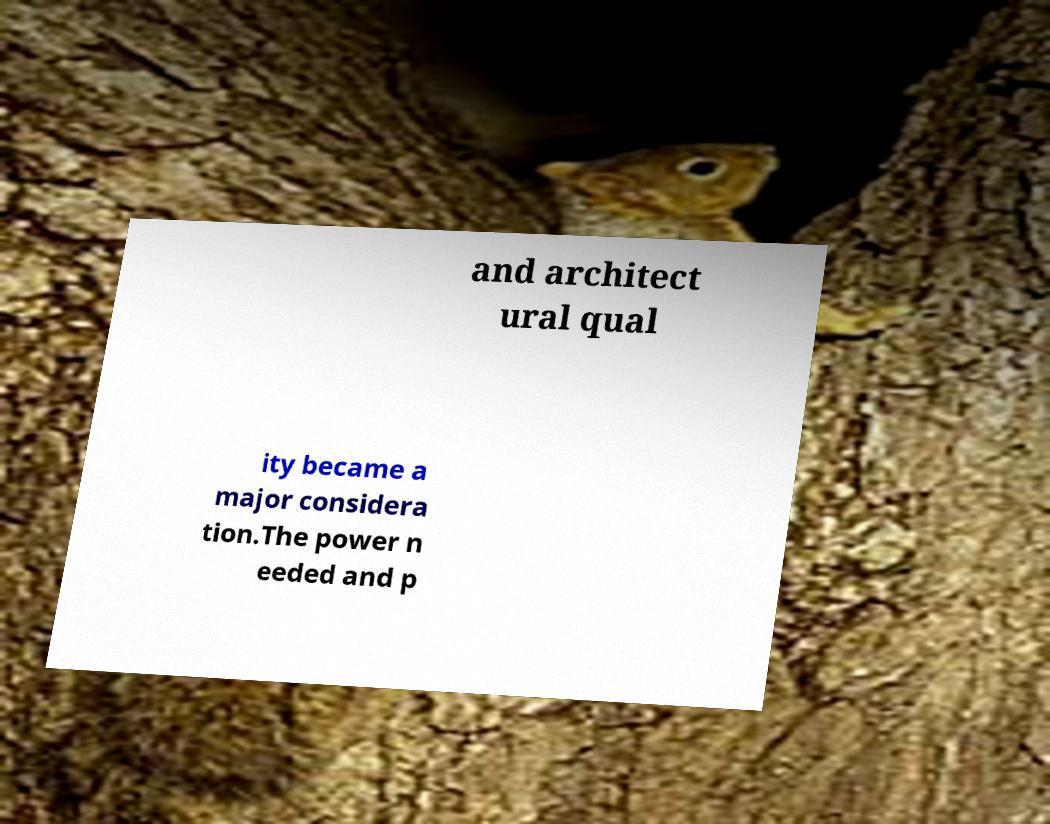There's text embedded in this image that I need extracted. Can you transcribe it verbatim? and architect ural qual ity became a major considera tion.The power n eeded and p 